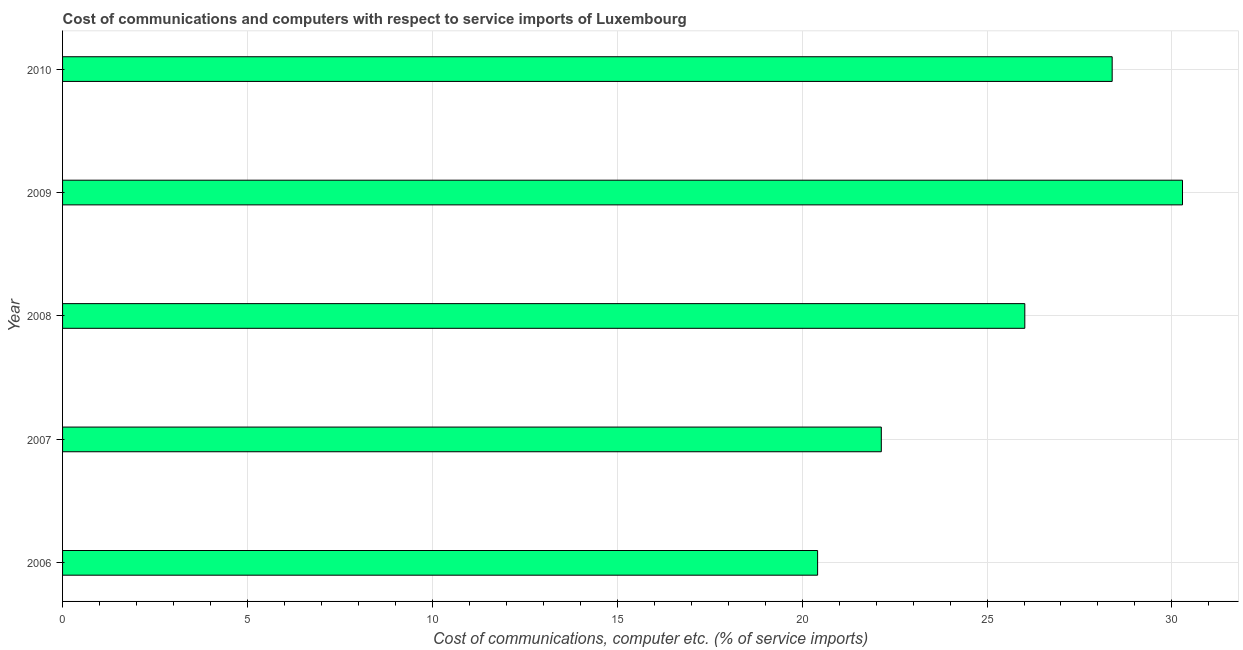Does the graph contain grids?
Make the answer very short. Yes. What is the title of the graph?
Give a very brief answer. Cost of communications and computers with respect to service imports of Luxembourg. What is the label or title of the X-axis?
Ensure brevity in your answer.  Cost of communications, computer etc. (% of service imports). What is the label or title of the Y-axis?
Your answer should be very brief. Year. What is the cost of communications and computer in 2006?
Provide a succinct answer. 20.42. Across all years, what is the maximum cost of communications and computer?
Give a very brief answer. 30.29. Across all years, what is the minimum cost of communications and computer?
Offer a terse response. 20.42. In which year was the cost of communications and computer maximum?
Your answer should be very brief. 2009. In which year was the cost of communications and computer minimum?
Provide a succinct answer. 2006. What is the sum of the cost of communications and computer?
Provide a succinct answer. 127.25. What is the difference between the cost of communications and computer in 2008 and 2009?
Offer a terse response. -4.26. What is the average cost of communications and computer per year?
Your response must be concise. 25.45. What is the median cost of communications and computer?
Ensure brevity in your answer.  26.02. In how many years, is the cost of communications and computer greater than 16 %?
Ensure brevity in your answer.  5. Do a majority of the years between 2010 and 2007 (inclusive) have cost of communications and computer greater than 7 %?
Your answer should be very brief. Yes. What is the ratio of the cost of communications and computer in 2008 to that in 2009?
Ensure brevity in your answer.  0.86. What is the difference between the highest and the second highest cost of communications and computer?
Make the answer very short. 1.9. What is the difference between the highest and the lowest cost of communications and computer?
Your answer should be very brief. 9.87. In how many years, is the cost of communications and computer greater than the average cost of communications and computer taken over all years?
Give a very brief answer. 3. How many bars are there?
Provide a short and direct response. 5. How many years are there in the graph?
Provide a short and direct response. 5. What is the difference between two consecutive major ticks on the X-axis?
Your response must be concise. 5. What is the Cost of communications, computer etc. (% of service imports) of 2006?
Give a very brief answer. 20.42. What is the Cost of communications, computer etc. (% of service imports) of 2007?
Keep it short and to the point. 22.14. What is the Cost of communications, computer etc. (% of service imports) in 2008?
Your response must be concise. 26.02. What is the Cost of communications, computer etc. (% of service imports) in 2009?
Your answer should be very brief. 30.29. What is the Cost of communications, computer etc. (% of service imports) in 2010?
Provide a short and direct response. 28.38. What is the difference between the Cost of communications, computer etc. (% of service imports) in 2006 and 2007?
Offer a terse response. -1.72. What is the difference between the Cost of communications, computer etc. (% of service imports) in 2006 and 2008?
Your answer should be compact. -5.6. What is the difference between the Cost of communications, computer etc. (% of service imports) in 2006 and 2009?
Provide a succinct answer. -9.87. What is the difference between the Cost of communications, computer etc. (% of service imports) in 2006 and 2010?
Your response must be concise. -7.97. What is the difference between the Cost of communications, computer etc. (% of service imports) in 2007 and 2008?
Your response must be concise. -3.88. What is the difference between the Cost of communications, computer etc. (% of service imports) in 2007 and 2009?
Offer a terse response. -8.14. What is the difference between the Cost of communications, computer etc. (% of service imports) in 2007 and 2010?
Make the answer very short. -6.24. What is the difference between the Cost of communications, computer etc. (% of service imports) in 2008 and 2009?
Provide a succinct answer. -4.26. What is the difference between the Cost of communications, computer etc. (% of service imports) in 2008 and 2010?
Keep it short and to the point. -2.36. What is the difference between the Cost of communications, computer etc. (% of service imports) in 2009 and 2010?
Make the answer very short. 1.9. What is the ratio of the Cost of communications, computer etc. (% of service imports) in 2006 to that in 2007?
Keep it short and to the point. 0.92. What is the ratio of the Cost of communications, computer etc. (% of service imports) in 2006 to that in 2008?
Your answer should be compact. 0.79. What is the ratio of the Cost of communications, computer etc. (% of service imports) in 2006 to that in 2009?
Give a very brief answer. 0.67. What is the ratio of the Cost of communications, computer etc. (% of service imports) in 2006 to that in 2010?
Your answer should be very brief. 0.72. What is the ratio of the Cost of communications, computer etc. (% of service imports) in 2007 to that in 2008?
Provide a short and direct response. 0.85. What is the ratio of the Cost of communications, computer etc. (% of service imports) in 2007 to that in 2009?
Provide a succinct answer. 0.73. What is the ratio of the Cost of communications, computer etc. (% of service imports) in 2007 to that in 2010?
Provide a succinct answer. 0.78. What is the ratio of the Cost of communications, computer etc. (% of service imports) in 2008 to that in 2009?
Provide a succinct answer. 0.86. What is the ratio of the Cost of communications, computer etc. (% of service imports) in 2008 to that in 2010?
Give a very brief answer. 0.92. What is the ratio of the Cost of communications, computer etc. (% of service imports) in 2009 to that in 2010?
Offer a very short reply. 1.07. 